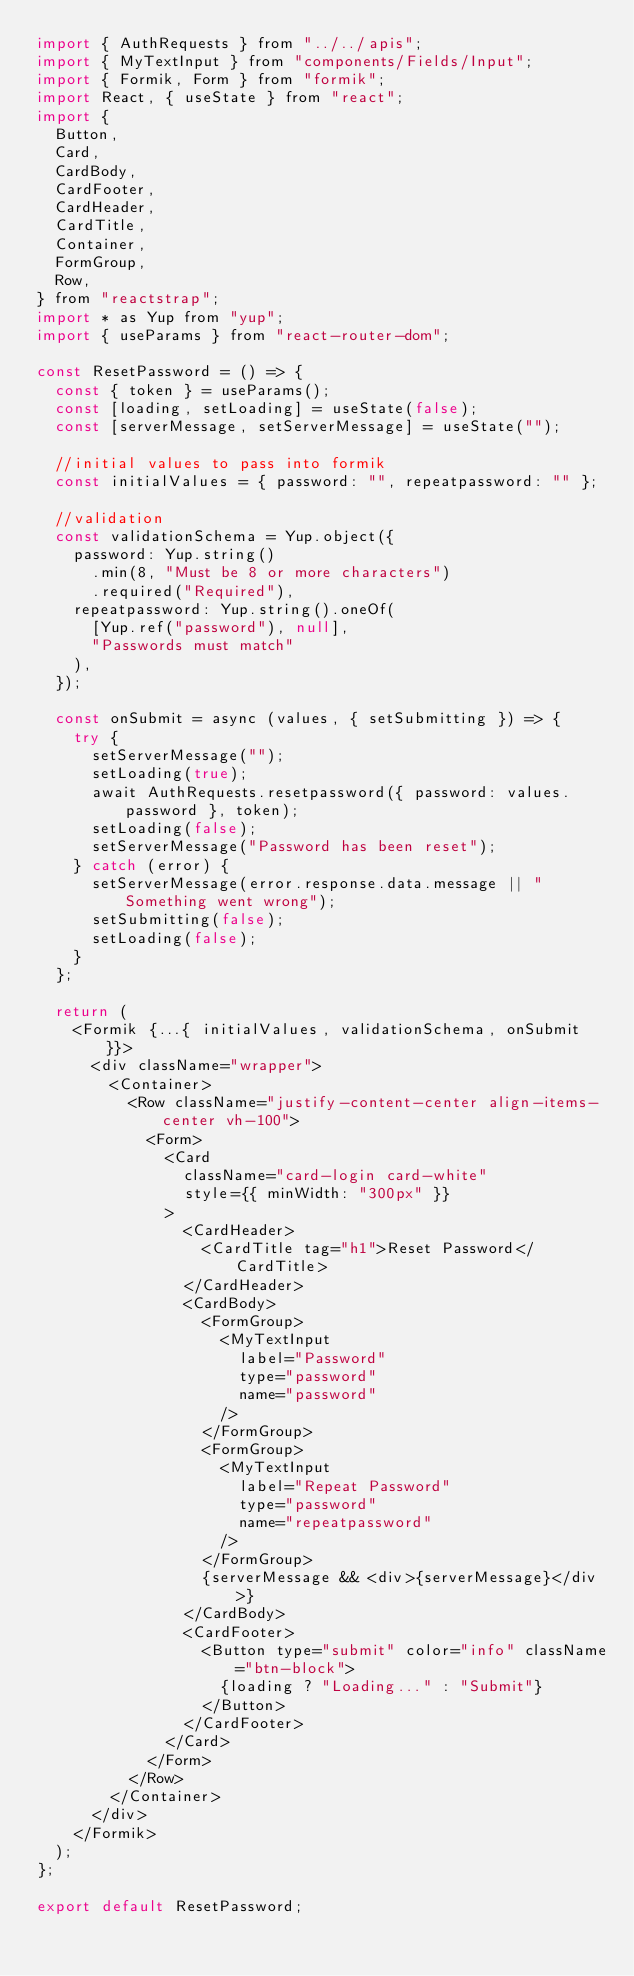<code> <loc_0><loc_0><loc_500><loc_500><_JavaScript_>import { AuthRequests } from "../../apis";
import { MyTextInput } from "components/Fields/Input";
import { Formik, Form } from "formik";
import React, { useState } from "react";
import {
  Button,
  Card,
  CardBody,
  CardFooter,
  CardHeader,
  CardTitle,
  Container,
  FormGroup,
  Row,
} from "reactstrap";
import * as Yup from "yup";
import { useParams } from "react-router-dom";

const ResetPassword = () => {
  const { token } = useParams();
  const [loading, setLoading] = useState(false);
  const [serverMessage, setServerMessage] = useState("");

  //initial values to pass into formik
  const initialValues = { password: "", repeatpassword: "" };

  //validation
  const validationSchema = Yup.object({
    password: Yup.string()
      .min(8, "Must be 8 or more characters")
      .required("Required"),
    repeatpassword: Yup.string().oneOf(
      [Yup.ref("password"), null],
      "Passwords must match"
    ),
  });

  const onSubmit = async (values, { setSubmitting }) => {
    try {
      setServerMessage("");
      setLoading(true);
      await AuthRequests.resetpassword({ password: values.password }, token);
      setLoading(false);
      setServerMessage("Password has been reset");
    } catch (error) {
      setServerMessage(error.response.data.message || "Something went wrong");
      setSubmitting(false);
      setLoading(false);
    }
  };

  return (
    <Formik {...{ initialValues, validationSchema, onSubmit }}>
      <div className="wrapper">
        <Container>
          <Row className="justify-content-center align-items-center vh-100">
            <Form>
              <Card
                className="card-login card-white"
                style={{ minWidth: "300px" }}
              >
                <CardHeader>
                  <CardTitle tag="h1">Reset Password</CardTitle>
                </CardHeader>
                <CardBody>
                  <FormGroup>
                    <MyTextInput
                      label="Password"
                      type="password"
                      name="password"
                    />
                  </FormGroup>
                  <FormGroup>
                    <MyTextInput
                      label="Repeat Password"
                      type="password"
                      name="repeatpassword"
                    />
                  </FormGroup>
                  {serverMessage && <div>{serverMessage}</div>}
                </CardBody>
                <CardFooter>
                  <Button type="submit" color="info" className="btn-block">
                    {loading ? "Loading..." : "Submit"}
                  </Button>
                </CardFooter>
              </Card>
            </Form>
          </Row>
        </Container>
      </div>
    </Formik>
  );
};

export default ResetPassword;
</code> 